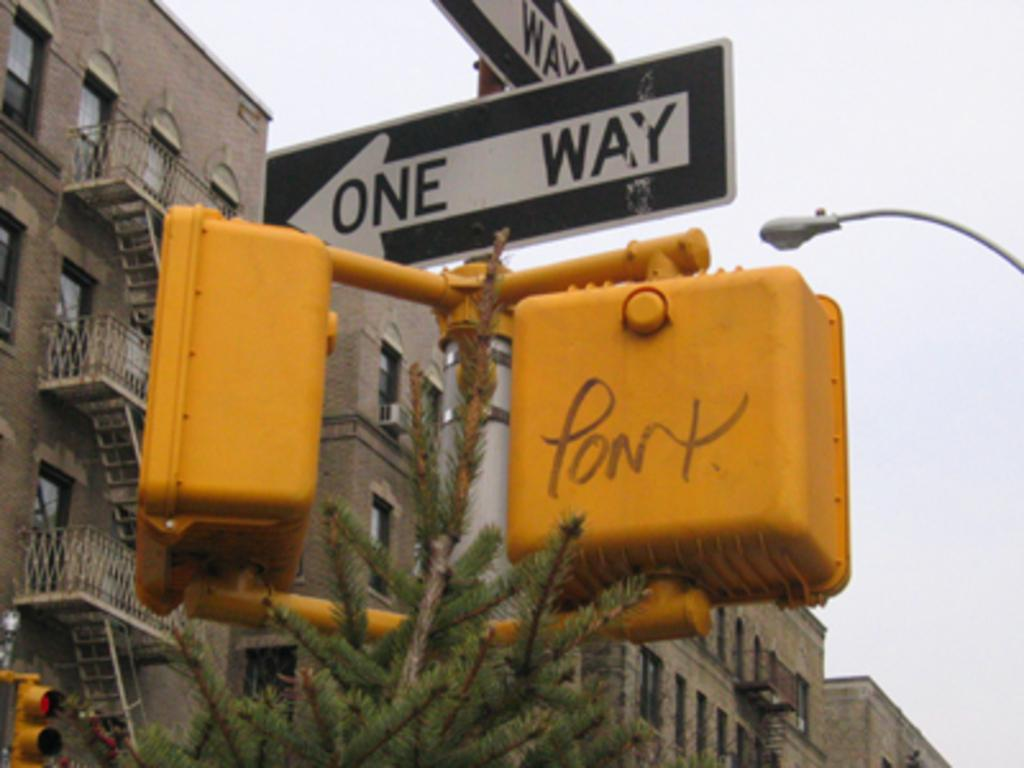<image>
Give a short and clear explanation of the subsequent image. The walk signal has some graffiti on it and then 2 one-way signs above it. 